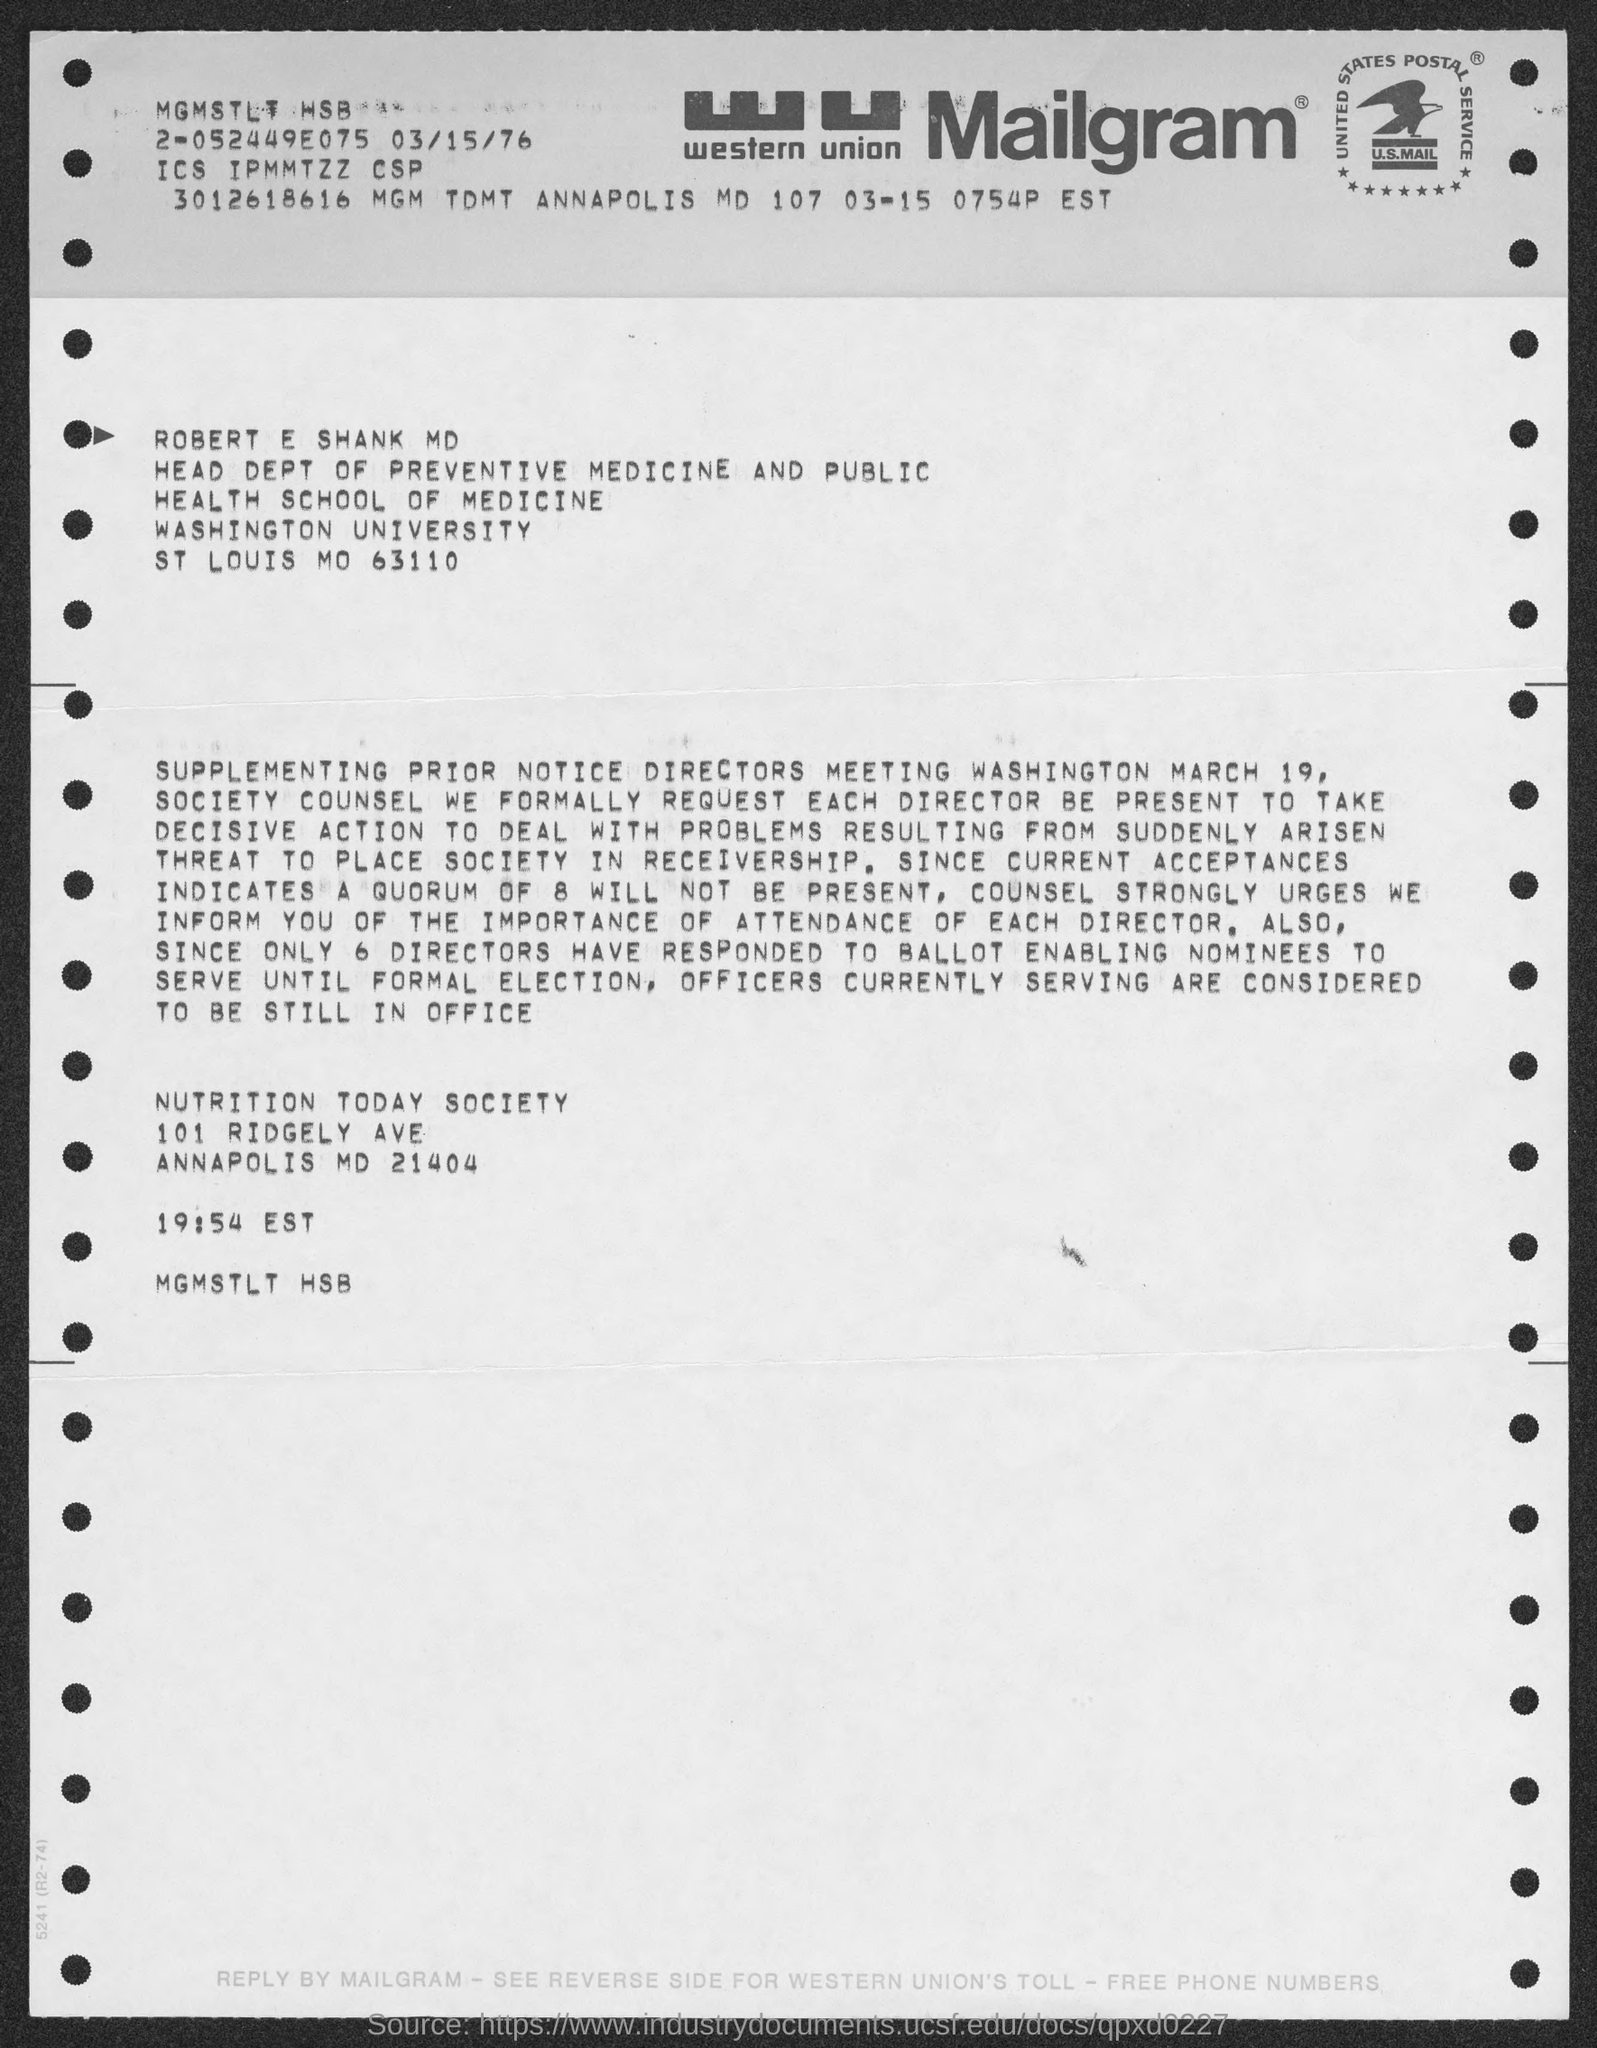Draw attention to some important aspects in this diagram. ROBERT E SHANK MD is the name mentioned in the mailgram. This is a kind of communication known as Mailgram. 